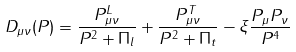Convert formula to latex. <formula><loc_0><loc_0><loc_500><loc_500>D _ { \mu \nu } ( P ) = \frac { P ^ { L } _ { \mu \nu } } { P ^ { 2 } + \Pi _ { l } } + \frac { P _ { \mu \nu } ^ { T } } { P ^ { 2 } + \Pi _ { t } } - \xi \frac { P _ { \mu } P _ { \nu } } { P ^ { 4 } }</formula> 